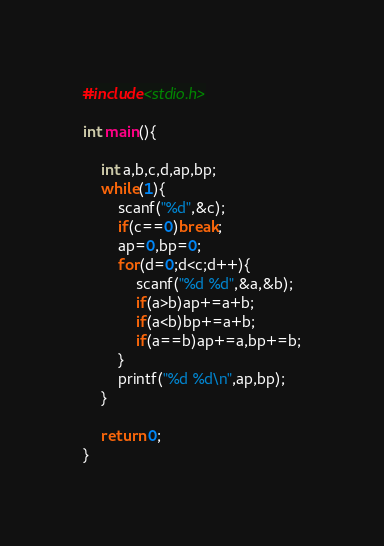Convert code to text. <code><loc_0><loc_0><loc_500><loc_500><_C_>#include<stdio.h>

int main(){
	
	int a,b,c,d,ap,bp;
	while(1){
		scanf("%d",&c);
		if(c==0)break;
		ap=0,bp=0;
		for(d=0;d<c;d++){
			scanf("%d %d",&a,&b);
			if(a>b)ap+=a+b;
			if(a<b)bp+=a+b;
			if(a==b)ap+=a,bp+=b;
		}
		printf("%d %d\n",ap,bp);
	}
	 
	return 0;
}</code> 